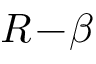<formula> <loc_0><loc_0><loc_500><loc_500>R \, - \, \beta</formula> 